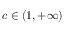<formula> <loc_0><loc_0><loc_500><loc_500>c \in ( 1 , + \infty )</formula> 